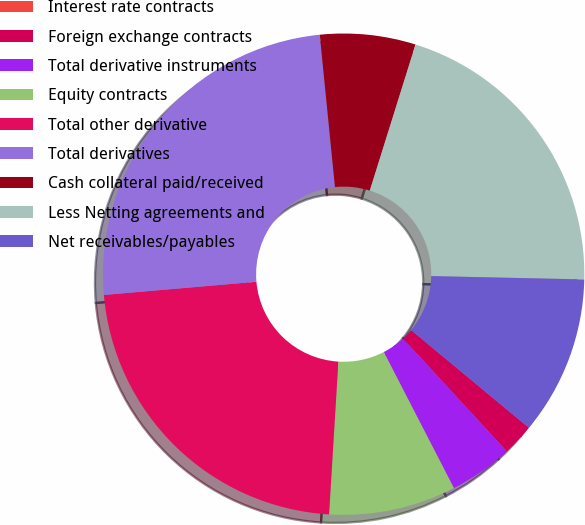<chart> <loc_0><loc_0><loc_500><loc_500><pie_chart><fcel>Interest rate contracts<fcel>Foreign exchange contracts<fcel>Total derivative instruments<fcel>Equity contracts<fcel>Total other derivative<fcel>Total derivatives<fcel>Cash collateral paid/received<fcel>Less Netting agreements and<fcel>Net receivables/payables<nl><fcel>0.0%<fcel>2.14%<fcel>4.27%<fcel>8.54%<fcel>22.66%<fcel>24.79%<fcel>6.41%<fcel>20.52%<fcel>10.67%<nl></chart> 